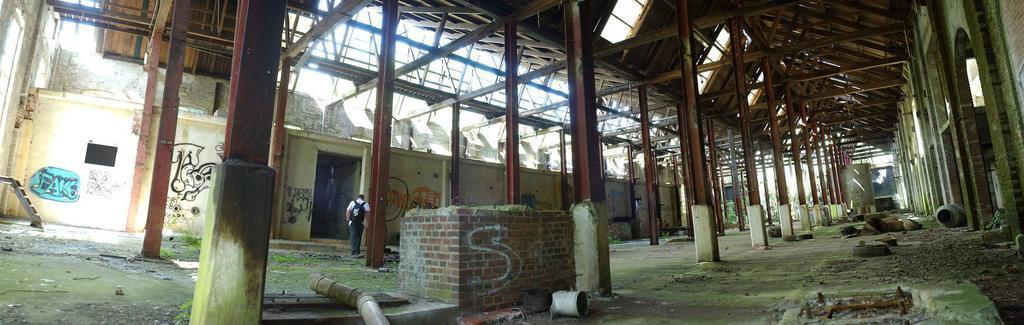Describe this image in one or two sentences. This is the picture of a shed. In this image there is a person walking. There is a text and painting on the wall. In the foreground there are pipes. At the back there are trees and poles. At the top there is sky. 